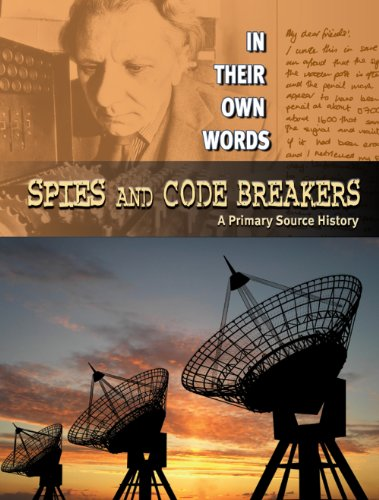Is this a kids book? Yes, it is a children's book, crafted to capture the young minds with exciting stories and facts from history. 